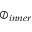Convert formula to latex. <formula><loc_0><loc_0><loc_500><loc_500>\oslash _ { i n n e r }</formula> 